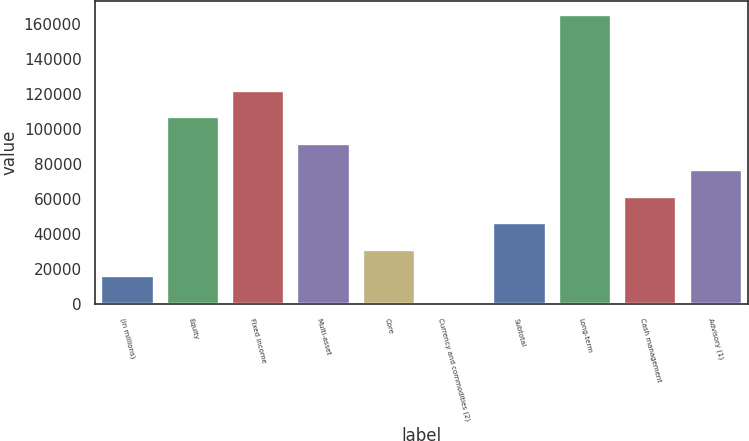Convert chart to OTSL. <chart><loc_0><loc_0><loc_500><loc_500><bar_chart><fcel>(in millions)<fcel>Equity<fcel>Fixed income<fcel>Multi-asset<fcel>Core<fcel>Currency and commodities (2)<fcel>Subtotal<fcel>Long-term<fcel>Cash management<fcel>Advisory (1)<nl><fcel>16141.9<fcel>106723<fcel>121820<fcel>91626.4<fcel>31238.8<fcel>1045<fcel>46335.7<fcel>164992<fcel>61432.6<fcel>76529.5<nl></chart> 